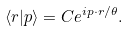Convert formula to latex. <formula><loc_0><loc_0><loc_500><loc_500>\langle { r } | { p } \rangle = C e ^ { i { p } \cdot { r } / \theta } .</formula> 